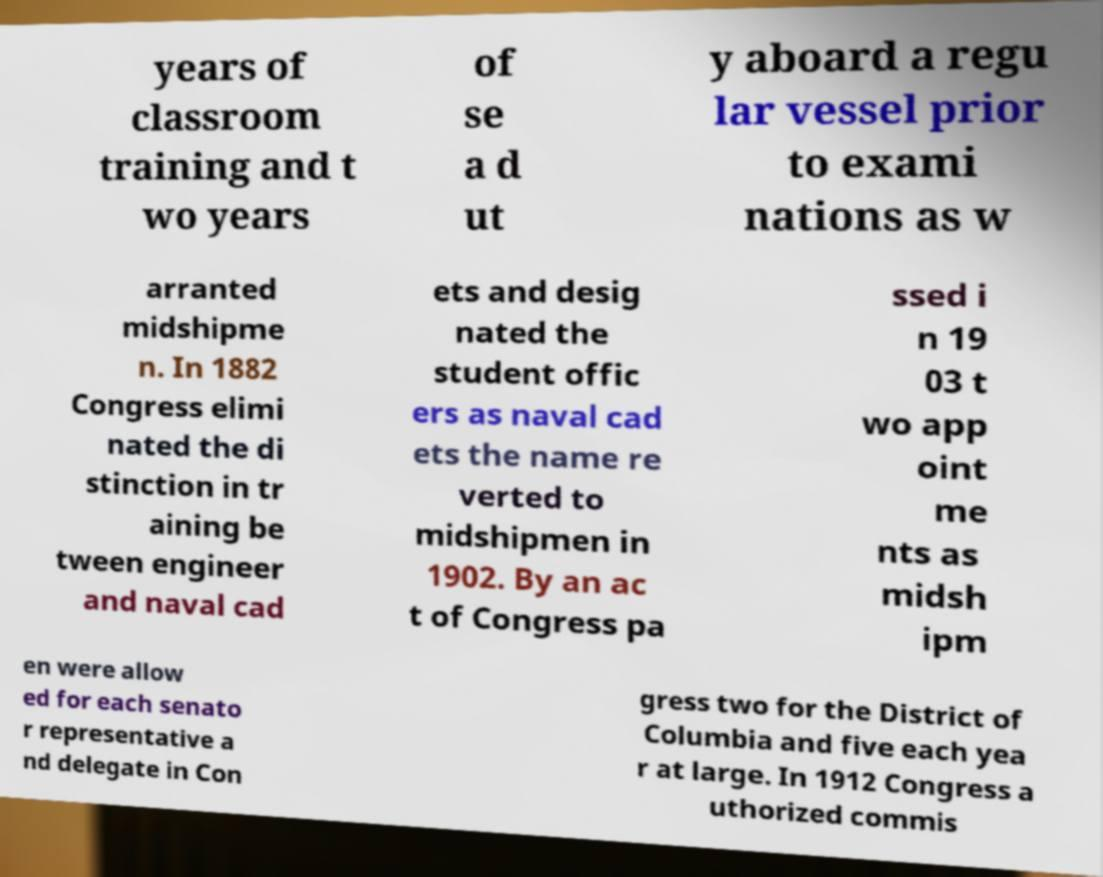Could you assist in decoding the text presented in this image and type it out clearly? years of classroom training and t wo years of se a d ut y aboard a regu lar vessel prior to exami nations as w arranted midshipme n. In 1882 Congress elimi nated the di stinction in tr aining be tween engineer and naval cad ets and desig nated the student offic ers as naval cad ets the name re verted to midshipmen in 1902. By an ac t of Congress pa ssed i n 19 03 t wo app oint me nts as midsh ipm en were allow ed for each senato r representative a nd delegate in Con gress two for the District of Columbia and five each yea r at large. In 1912 Congress a uthorized commis 